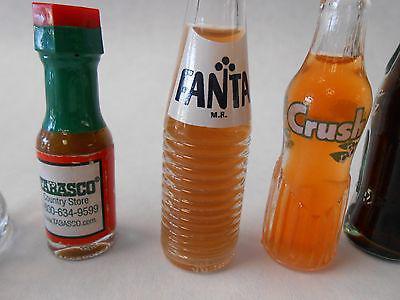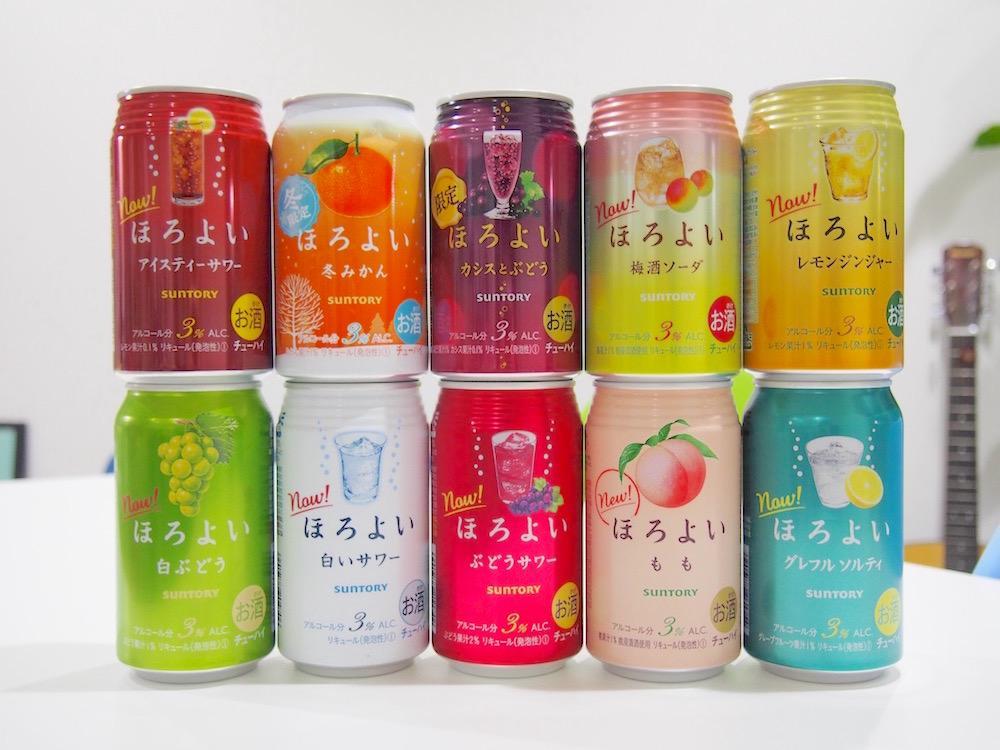The first image is the image on the left, the second image is the image on the right. Examine the images to the left and right. Is the description "There are exactly six bottles in the right image." accurate? Answer yes or no. No. The first image is the image on the left, the second image is the image on the right. Examine the images to the left and right. Is the description "The left image features a row of at least six empty soda bottles without lids, and the right image shows exactly six filled bottles of soda with caps on." accurate? Answer yes or no. No. 